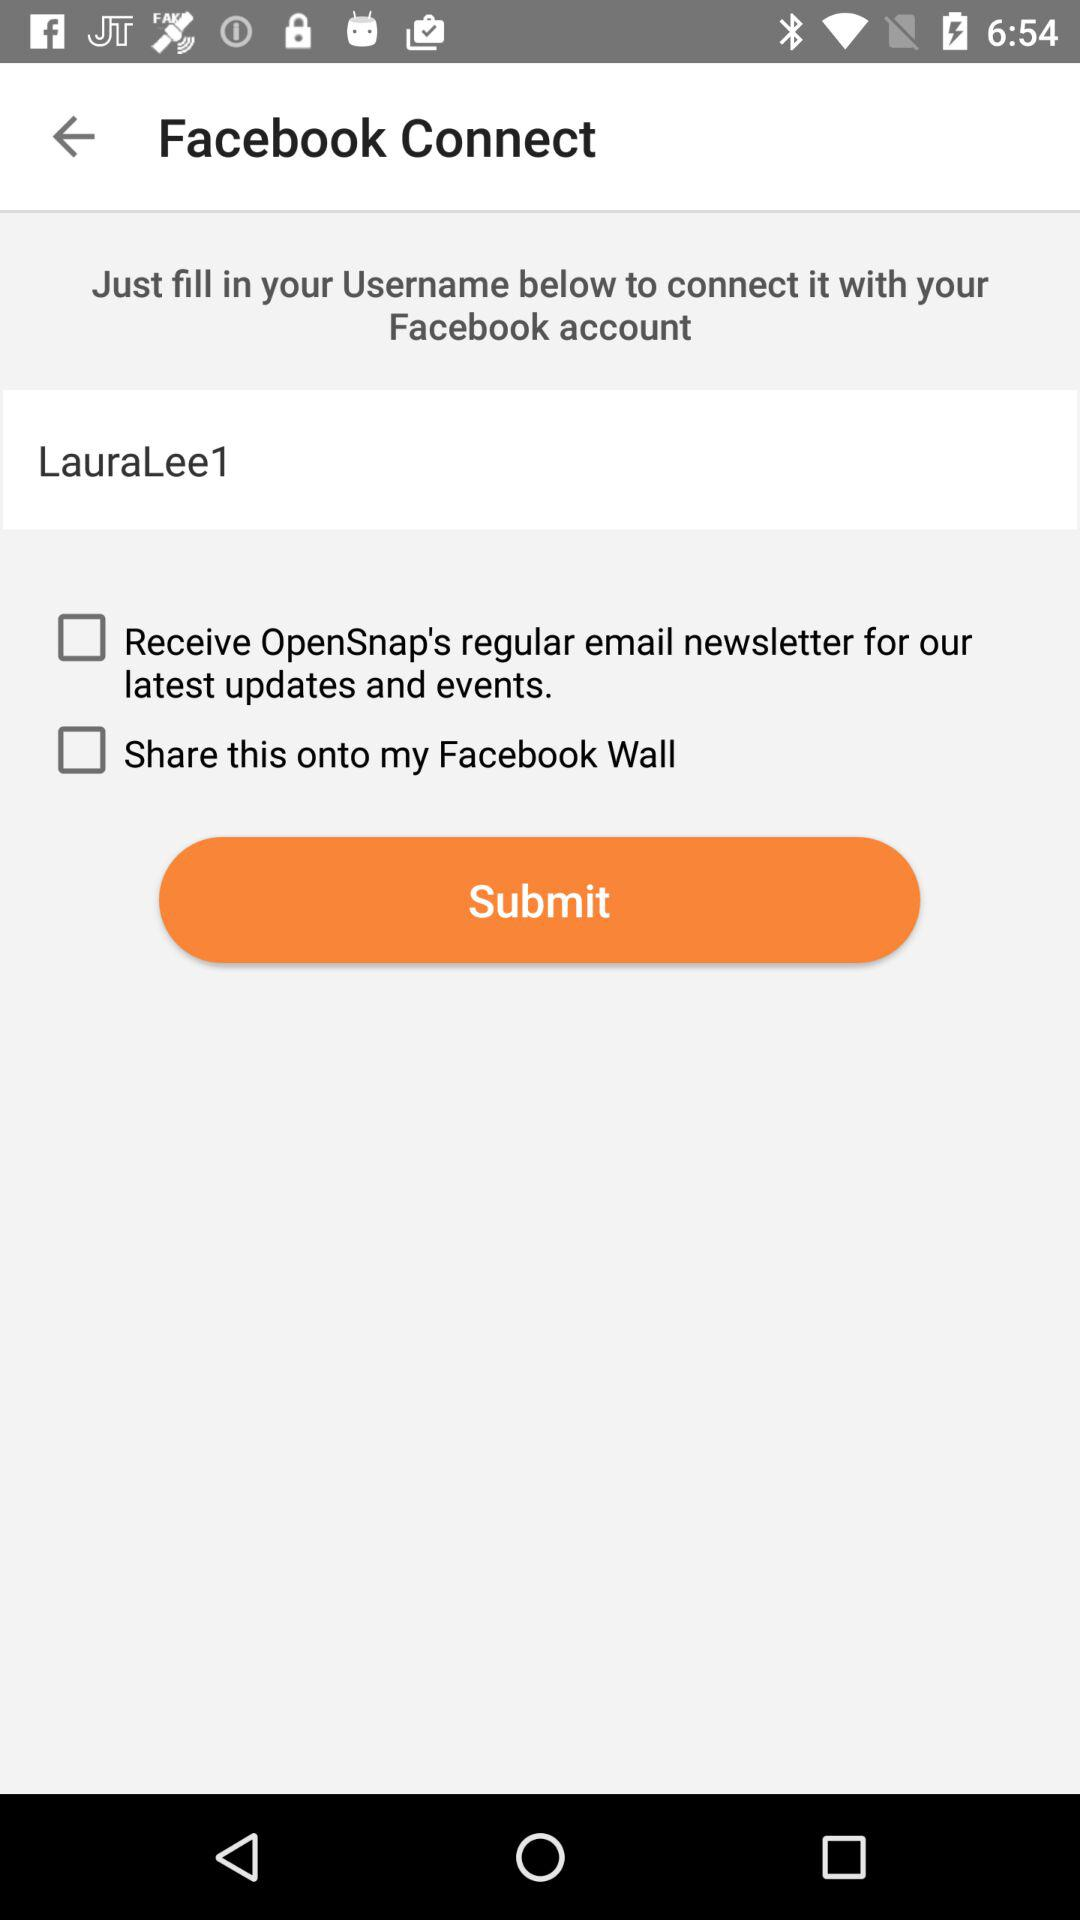How many checkboxes are available?
Answer the question using a single word or phrase. 2 